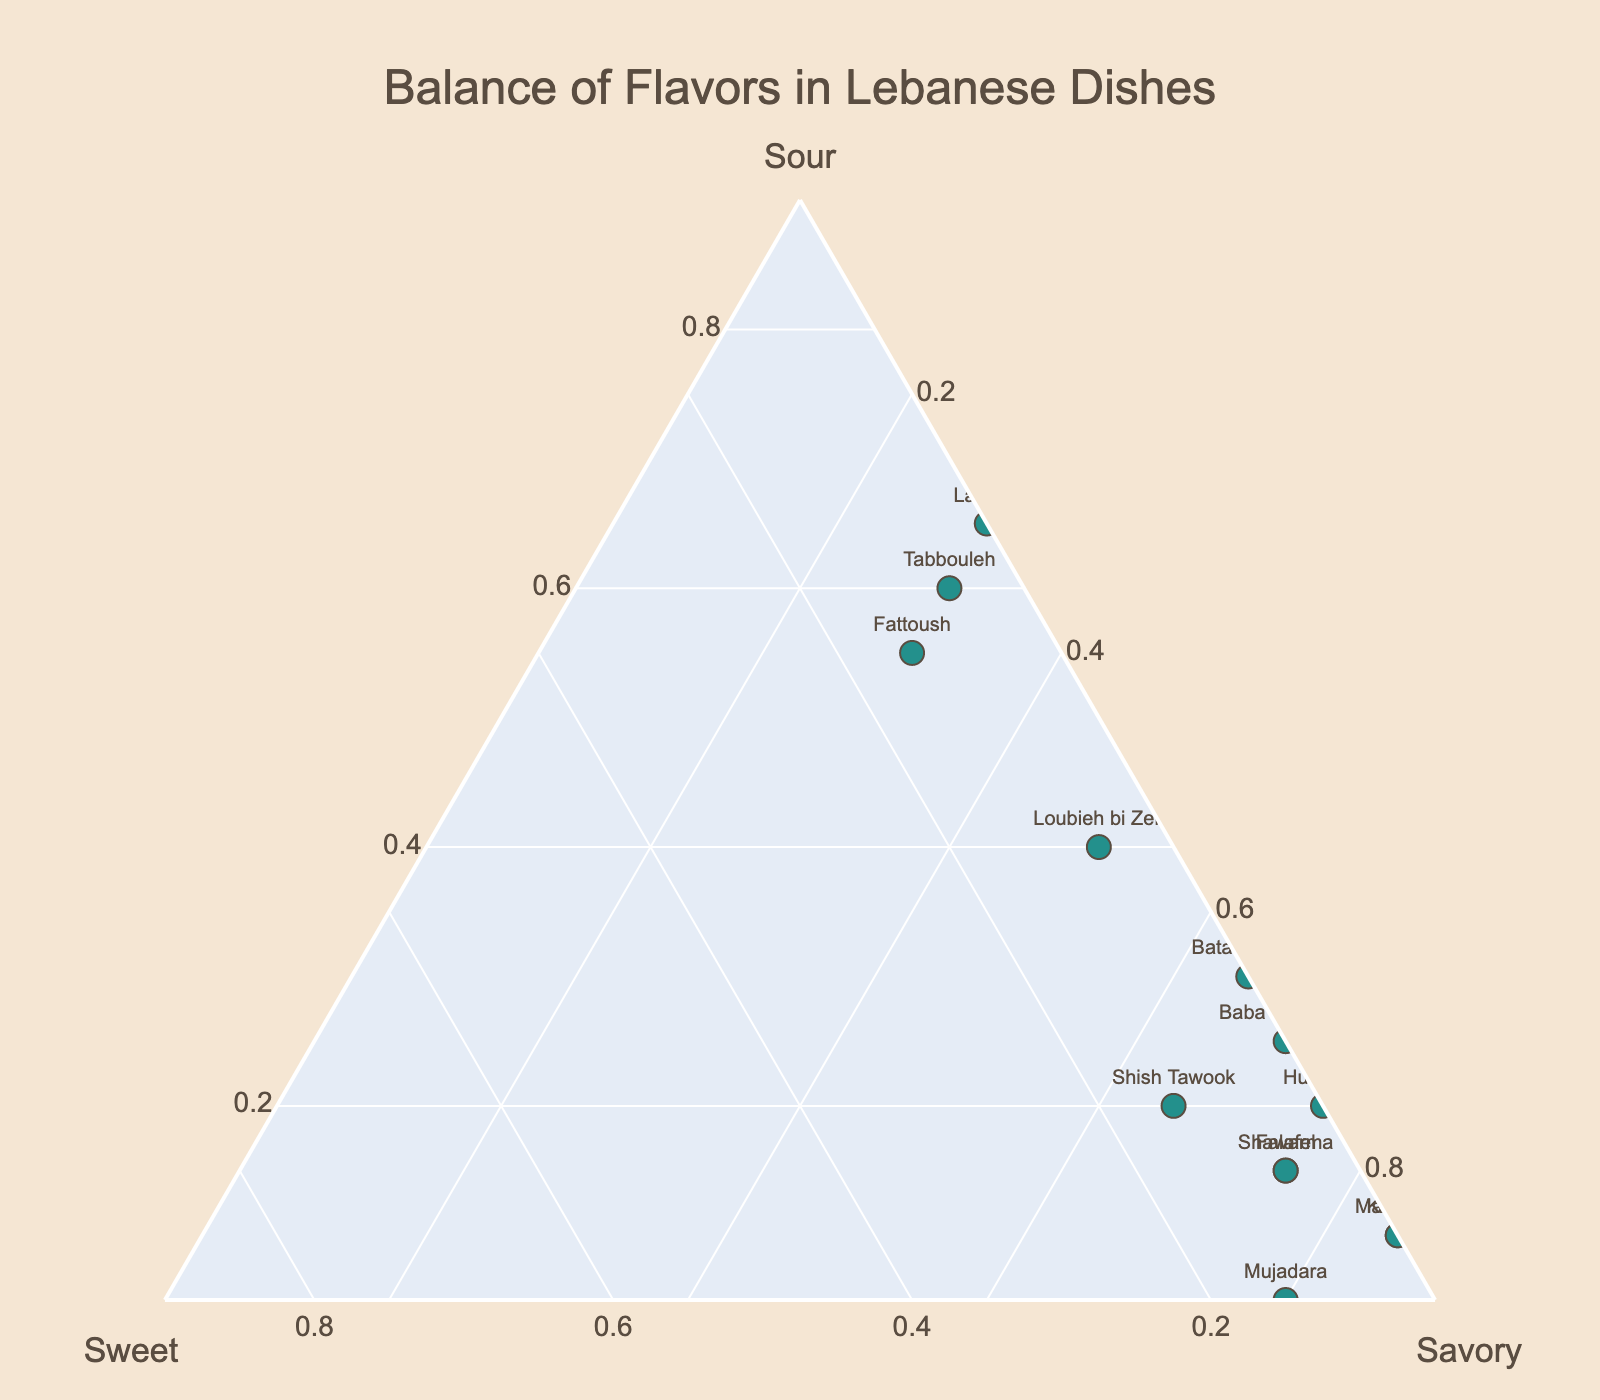Which dish has the highest proportion of sour flavor? Look for the dish with the highest value on the 'Sour' axis. Labneh has the highest normalized sour value of 0.65 (or 65%).
Answer: Labneh Which dish has the highest balance of savory flavor? Observe the points furthest along the 'Savory' axis. Dishes like Kibbeh, Manakish, and Hummus have the highest savory values with Kibbeh and Manakish sharing the same top value of 0.85.
Answer: Kibbeh and Manakish Which dish has the highest total flavor balance? The color intensity represents the total balance of flavors across dishes. Kibbeh and Manakish both have the brightest color, indicating a high total value.
Answer: Kibbeh and Manakish What is the sour-to-sweet ratio in Tabbouleh? Look at the normalized values for 'Sour' and 'Sweet' in Tabbouleh. The ratio is calculated by dividing the sour proportion (0.60) by the sweet proportion (0.10).
Answer: 6:1 How does Fattoush's sweet flavor compare to Shish Tawook's sweet flavor? Compare the points on the 'Sweet' axis for Fattoush and Shish Tawook. Fattoush has a normalized sweet value of 0.15, slightly higher than Shish Tawook’s 0.15.
Answer: Equal Which dish has the closest balance between sour and savory flavors? Search for dishes where the sour and savory proportions are closest. Loubieh bi Zeit, with sour at 0.40 and savory at 0.50, presents the closest balance.
Answer: Loubieh bi Zeit Which dish is located at the intersection of high sour and low sweet flavors? Identify dishes with high sour values but low sweet values. Labneh stands out with a high sour value (0.65) and low sweet value (0.05).
Answer: Labneh Is there a dish with an equal balance of sweet and savory flavors? Look for dishes where the values of sweet and savory are nearly equal. Baba Ganoush and Batata Harra both have normalized sweet values of 0.05 and similar savory values (0.70 for Baba Ganoush, 0.65 for Batata Harra).
Answer: Baba Ganoush and Batata Harra 